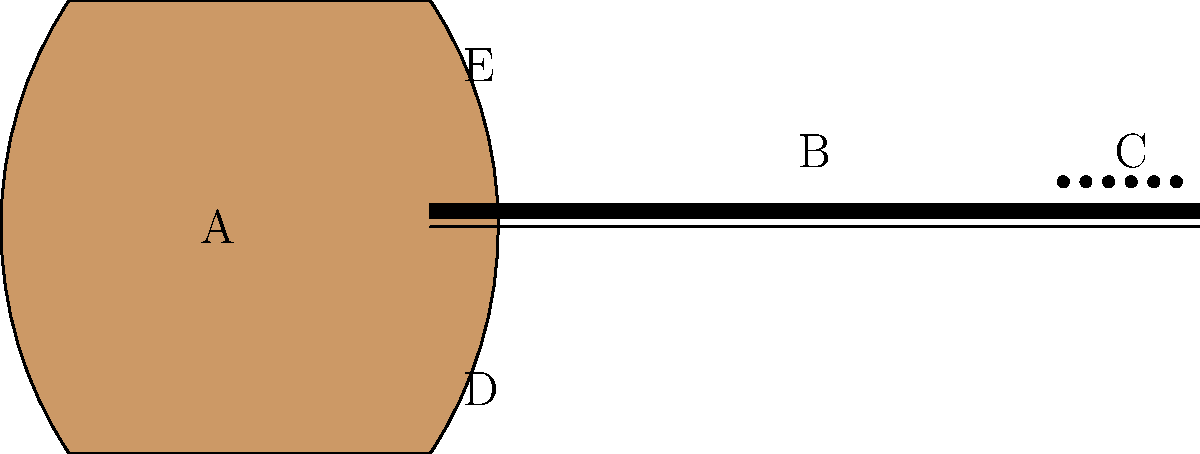Identify the parts of this traditional Indian musical instrument, the sitar. Match the labels A-E with the correct part names: resonating chamber, frets, tuning pegs, main playing strings, and sympathetic strings. To correctly identify the parts of the sitar, let's go through each label step-by-step:

1. Label A points to the large, rounded part of the instrument. This is the resonating chamber, which amplifies the sound produced by the strings.

2. Label B indicates the long, straight part of the instrument where the player's fingers press down. This area contains raised metal strips called frets, which help in producing different notes.

3. Label C points to small dots at the top of the instrument. These are the tuning pegs, used to adjust the tension and pitch of the strings.

4. Label D indicates the strings that run along the entire length of the instrument. These are the main playing strings, which the musician plucks to produce melodies.

5. Label E points to additional strings visible near the resonating chamber. These are the sympathetic strings, which are not directly played but vibrate in response to the main strings, adding depth and richness to the sound.

By understanding the function of each part and matching it to the corresponding label, we can correctly identify all components of the sitar.
Answer: A: resonating chamber, B: frets, C: tuning pegs, D: main playing strings, E: sympathetic strings 